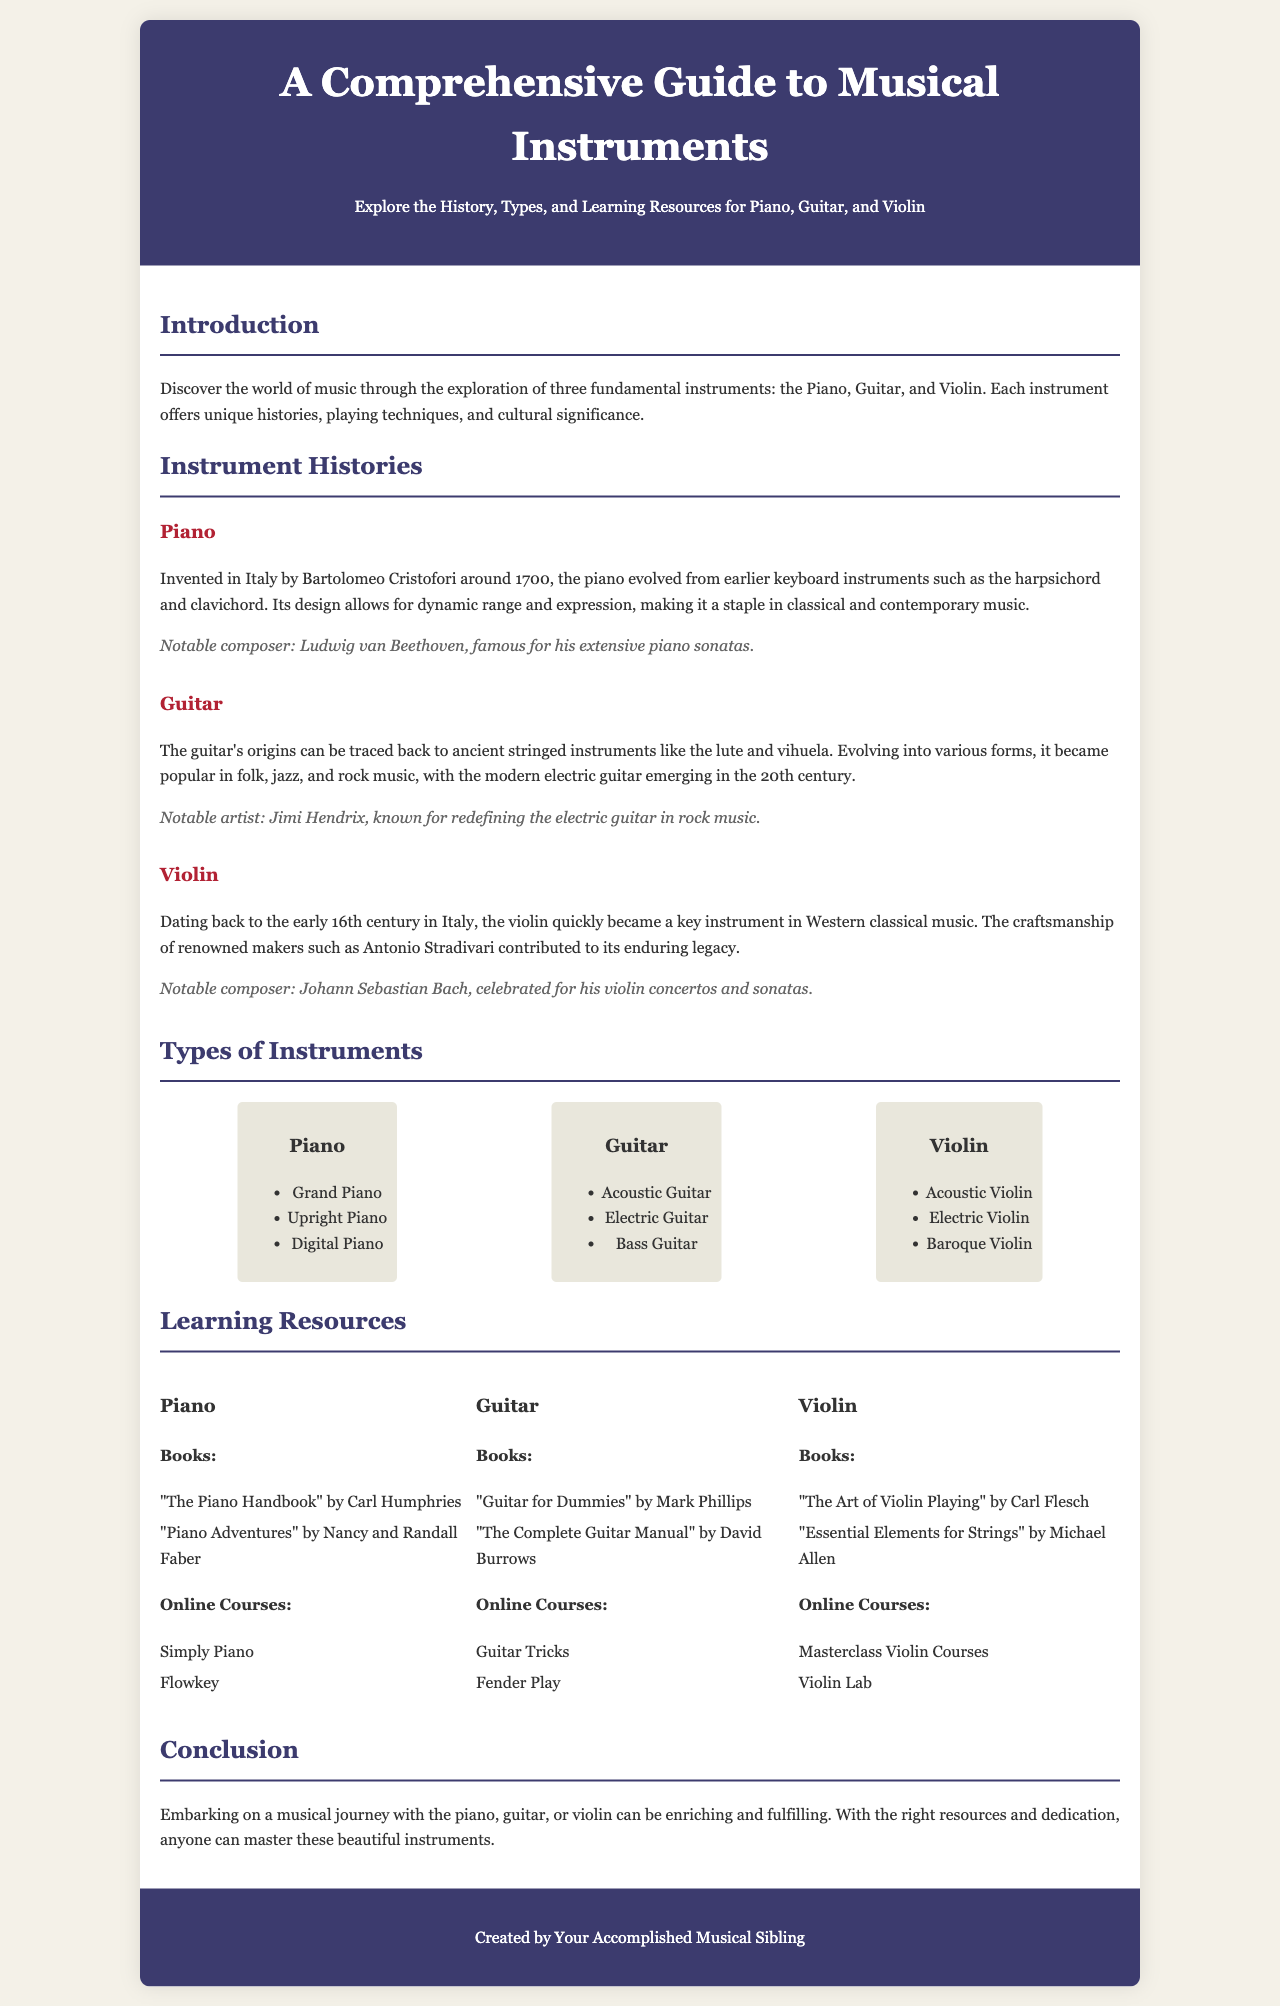What year was the piano invented? The piano was invented around 1700.
Answer: 1700 Who invented the piano? The piano was invented by Bartolomeo Cristofori.
Answer: Bartolomeo Cristofori Which instrument is known for notable composer Ludwig van Beethoven? The notable composer Ludwig van Beethoven is associated with the piano.
Answer: Piano What are the three types of guitars listed? The three types of guitars are Acoustic Guitar, Electric Guitar, and Bass Guitar.
Answer: Acoustic Guitar, Electric Guitar, Bass Guitar Which book is associated with learning the guitar? "Guitar for Dummies" by Mark Phillips is one of the books listed for learning the guitar.
Answer: "Guitar for Dummies" What is the cultural significance of the violin mentioned in the document? The violin is a key instrument in Western classical music.
Answer: Key instrument in Western classical music How many online courses are mentioned for learning the violin? There are two online courses mentioned for learning the violin.
Answer: 2 What notable artist is linked to the guitar? Jimi Hendrix is known as a notable artist linked to the guitar.
Answer: Jimi Hendrix What does the conclusion suggest about learning these instruments? The conclusion suggests that with the right resources and dedication, anyone can master these instruments.
Answer: Anyone can master these instruments 